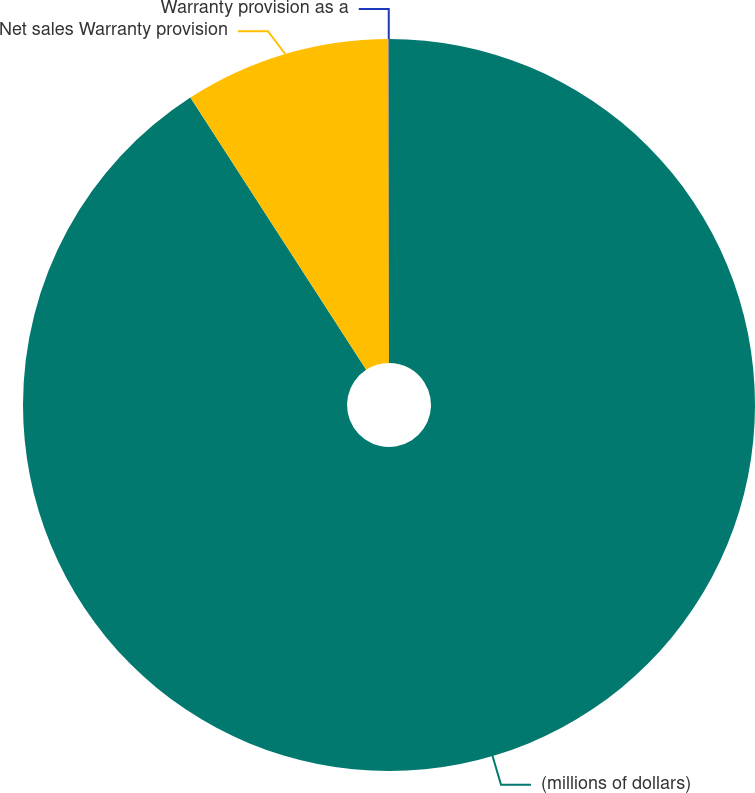Convert chart. <chart><loc_0><loc_0><loc_500><loc_500><pie_chart><fcel>(millions of dollars)<fcel>Net sales Warranty provision<fcel>Warranty provision as a<nl><fcel>90.87%<fcel>9.11%<fcel>0.02%<nl></chart> 